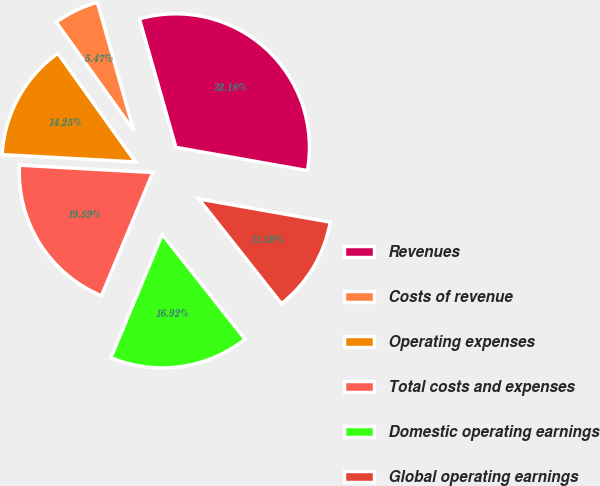Convert chart to OTSL. <chart><loc_0><loc_0><loc_500><loc_500><pie_chart><fcel>Revenues<fcel>Costs of revenue<fcel>Operating expenses<fcel>Total costs and expenses<fcel>Domestic operating earnings<fcel>Global operating earnings<nl><fcel>32.18%<fcel>5.47%<fcel>14.25%<fcel>19.59%<fcel>16.92%<fcel>11.58%<nl></chart> 